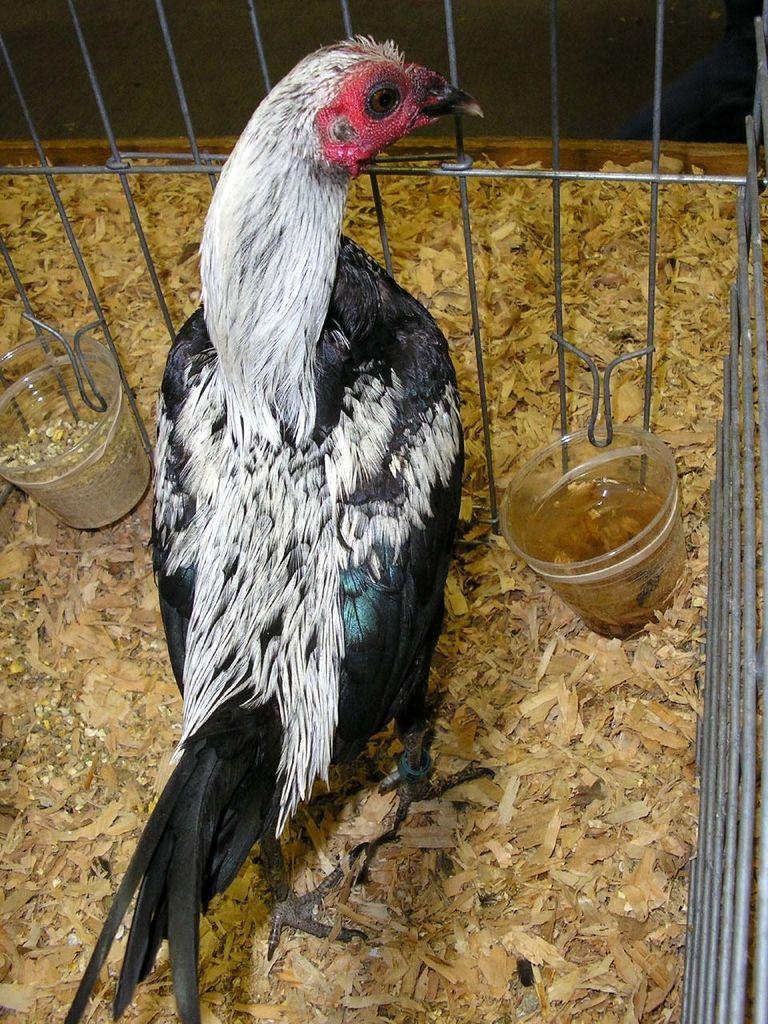Describe this image in one or two sentences. In this image there is a hen in a cage, besides the hen there are two glasses with water and some grains in it, on the surface there are feathers and some objects. 